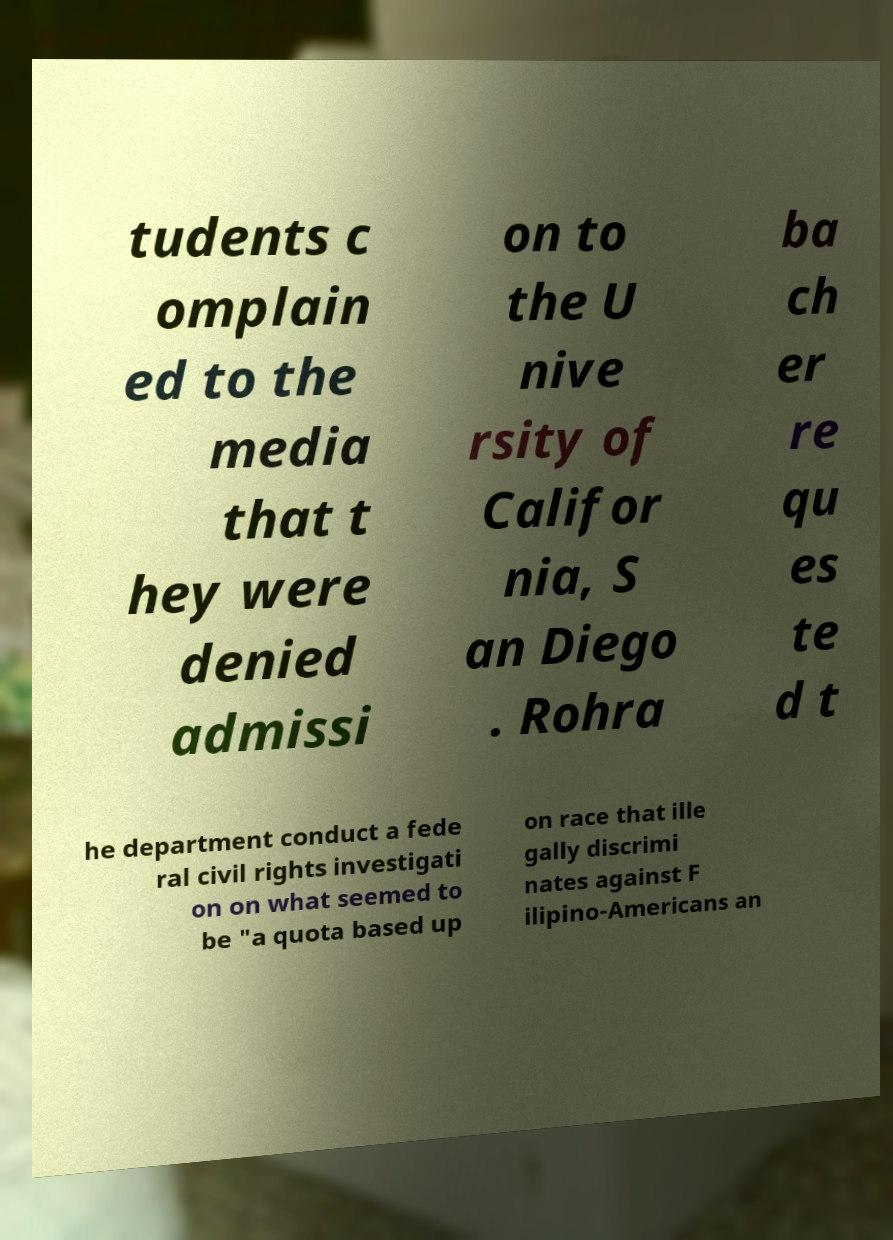What messages or text are displayed in this image? I need them in a readable, typed format. tudents c omplain ed to the media that t hey were denied admissi on to the U nive rsity of Califor nia, S an Diego . Rohra ba ch er re qu es te d t he department conduct a fede ral civil rights investigati on on what seemed to be "a quota based up on race that ille gally discrimi nates against F ilipino-Americans an 